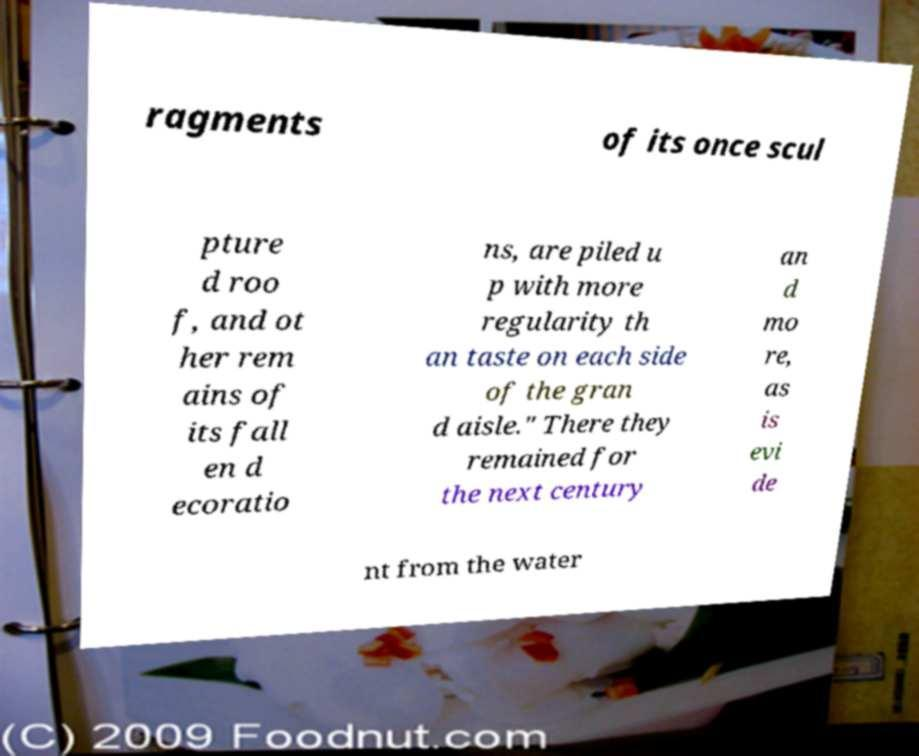There's text embedded in this image that I need extracted. Can you transcribe it verbatim? ragments of its once scul pture d roo f, and ot her rem ains of its fall en d ecoratio ns, are piled u p with more regularity th an taste on each side of the gran d aisle." There they remained for the next century an d mo re, as is evi de nt from the water 